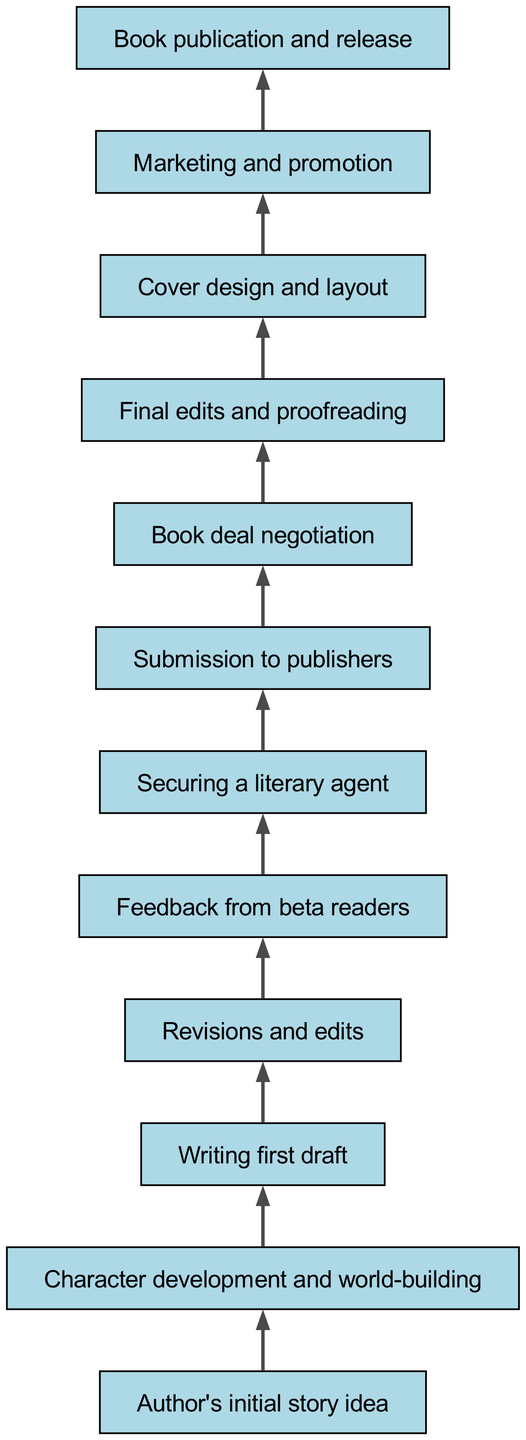What is the first step in the evolution of the book series? The diagram indicates that the first step is the "Author's initial story idea". This is the first node in the flow chart, which signifies the starting point of the book's development.
Answer: Author's initial story idea How many nodes are in the diagram? By counting each distinct step in the flowchart, we find there are twelve nodes listed. Each one represents a specific stage in the book's evolution, from concept to publication.
Answer: 12 What follows after "Character development and world-building"? Looking at the connections in the diagram, the next step after "Character development and world-building" is "Writing first draft". This shows the progression from developing ideas to drafting the text.
Answer: Writing first draft What is the penultimate step before the book's release? To determine the second to last step, we trace back from "Book publication and release", which points to "Marketing and promotion". Thus, this indicates that marketing efforts occur right before the book is released.
Answer: Marketing and promotion Which stage involves gathering feedback on the manuscript? The diagram points out that the stage where feedback is gathered comes after the "Revisions and edits", indicated by the "Feedback from beta readers". This step is essential to refine the manuscript further.
Answer: Feedback from beta readers What is the final step in the publication process? According to the flow in the chart, the final step is "Book publication and release", which reflects the culmination of all prior efforts to bring the book to readers.
Answer: Book publication and release What is the relationship between "Final edits and proofreading" and "Cover design and layout"? The diagram shows that "Final edits and proofreading" leads directly to "Cover design and layout". This means that after editing is completed, the design of the book's cover is undertaken.
Answer: Final edits and proofreading leads to Cover design and layout How do authors usually secure literary representation? The flowchart indicates that authors typically secure a literary agent after receiving feedback from beta readers. This sequence signifies that aiming for representation often follows initial evaluations of the manuscript.
Answer: Securing a literary agent after feedback from beta readers 